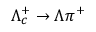Convert formula to latex. <formula><loc_0><loc_0><loc_500><loc_500>\Lambda _ { c } ^ { + } \to \Lambda \pi ^ { + }</formula> 